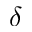Convert formula to latex. <formula><loc_0><loc_0><loc_500><loc_500>\delta</formula> 